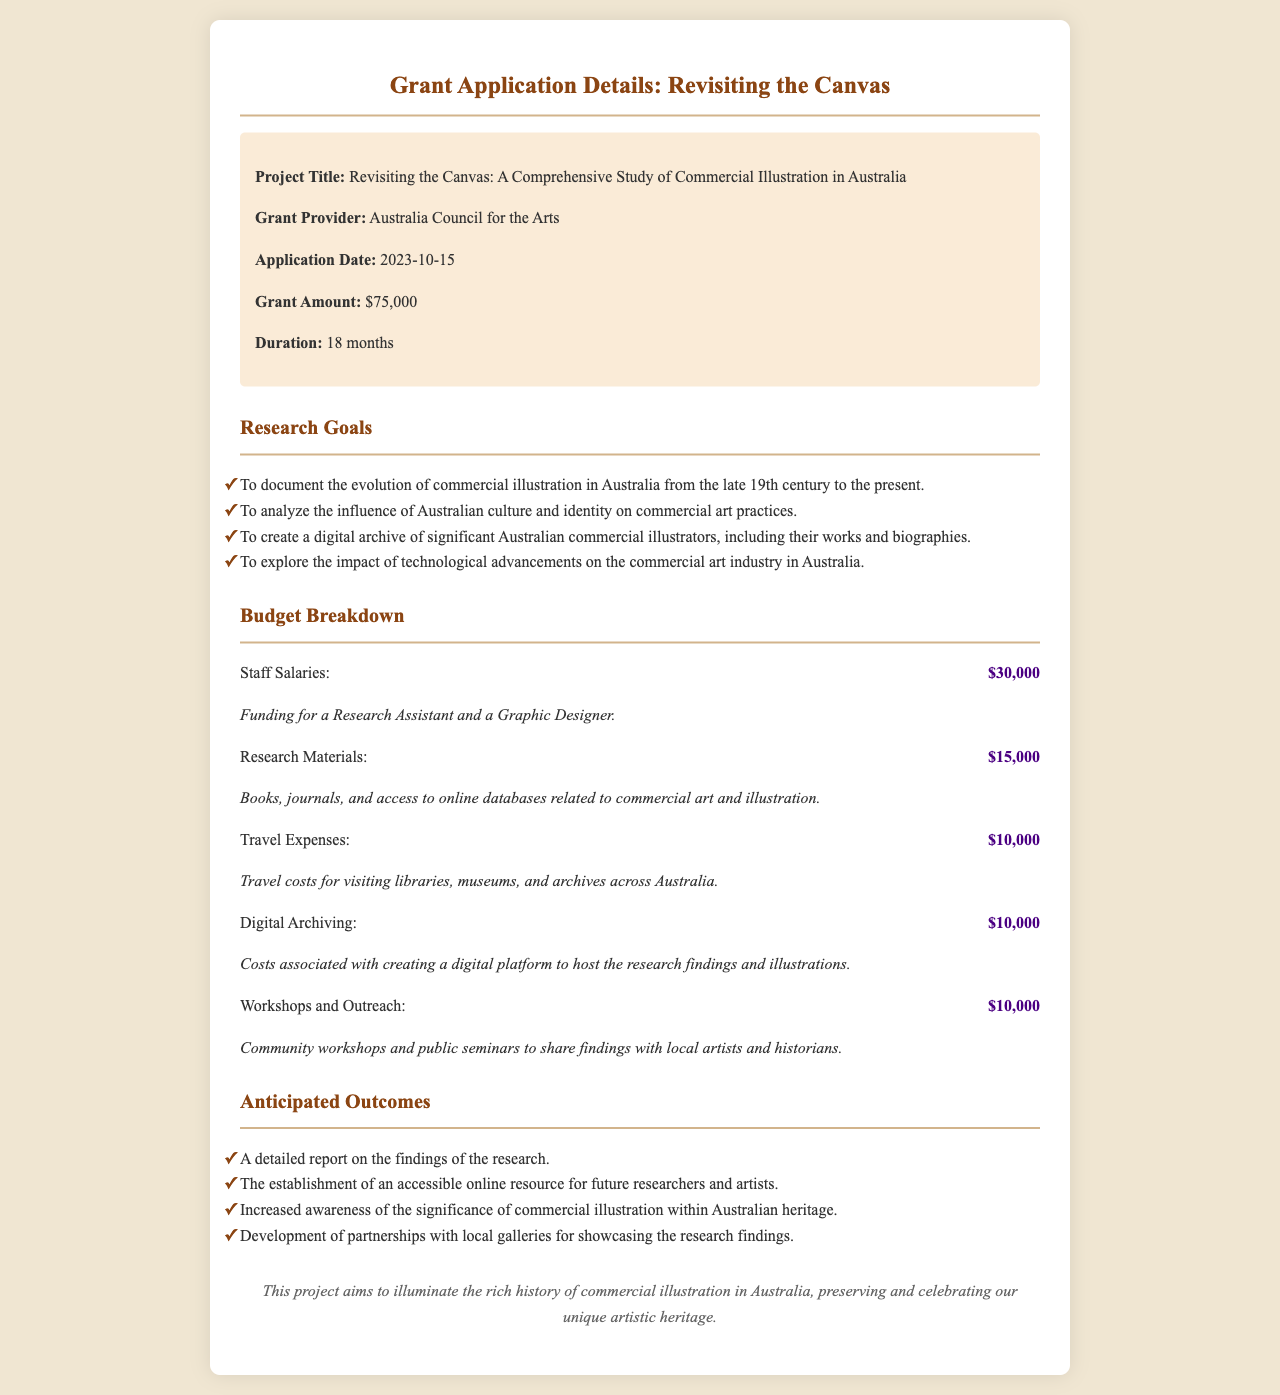What is the project title? The project title is explicitly mentioned in the document as "Revisiting the Canvas: A Comprehensive Study of Commercial Illustration in Australia."
Answer: Revisiting the Canvas: A Comprehensive Study of Commercial Illustration in Australia Who is the grant provider? The grant provider's name is specified in the document as the organization funding the project.
Answer: Australia Council for the Arts What is the total grant amount? The total grant amount is stated in the document as $75,000.
Answer: $75,000 How long is the project duration? The duration of the project is given in the document as 18 months.
Answer: 18 months What is the budget for research materials? The budget allocation for research materials is detailed in the budget breakdown section of the document.
Answer: $15,000 What are the anticipated outcomes? The anticipated outcomes section lists the expected results from the research, which includes awareness of commercial illustration significance.
Answer: Increased awareness of the significance of commercial illustration within Australian heritage What is one goal of the research? One goal of the research is provided in the document, focusing on the evolution of a specific art form in Australia.
Answer: To document the evolution of commercial illustration in Australia from the late 19th century to the present How much is allocated for travel expenses? The document specifies the funding allocated for travel expenses as part of the project's budget.
Answer: $10,000 What type of outreach is planned for the project? The document mentions the form of outreach activities planned to engage the community with the project's findings.
Answer: Community workshops and public seminars 